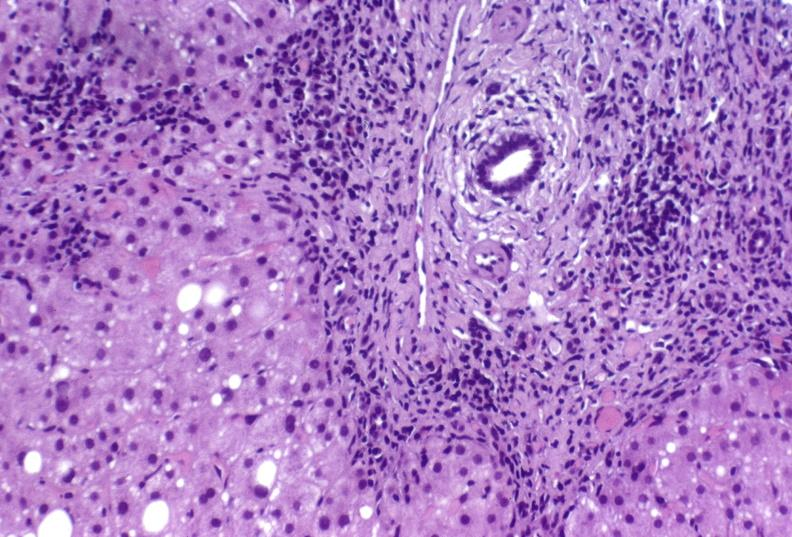s liver present?
Answer the question using a single word or phrase. Yes 